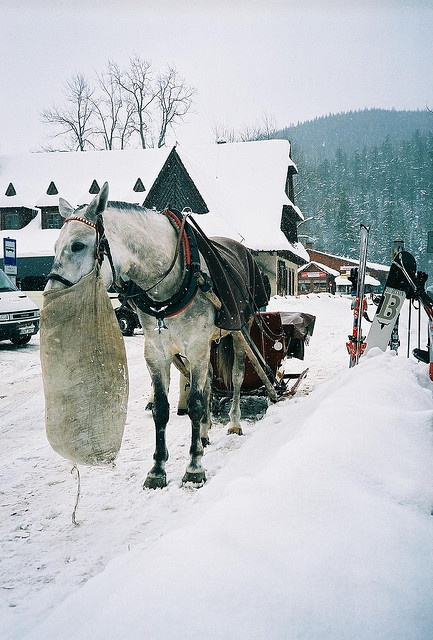Describe the objects in this image and their specific colors. I can see horse in lightgray, black, darkgray, and gray tones, snowboard in lightgray, black, darkgray, and gray tones, car in lightgray, black, darkgray, and teal tones, and skis in lightgray, darkgray, gray, and black tones in this image. 